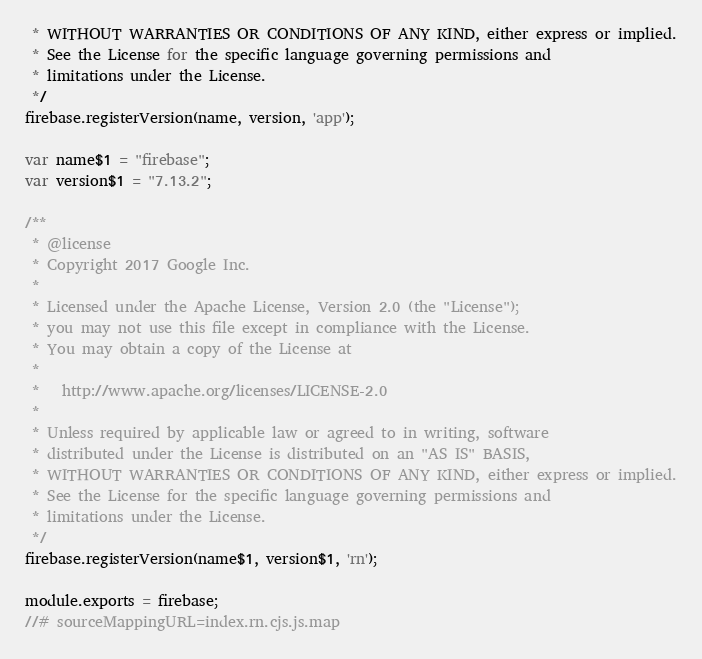<code> <loc_0><loc_0><loc_500><loc_500><_JavaScript_> * WITHOUT WARRANTIES OR CONDITIONS OF ANY KIND, either express or implied.
 * See the License for the specific language governing permissions and
 * limitations under the License.
 */
firebase.registerVersion(name, version, 'app');

var name$1 = "firebase";
var version$1 = "7.13.2";

/**
 * @license
 * Copyright 2017 Google Inc.
 *
 * Licensed under the Apache License, Version 2.0 (the "License");
 * you may not use this file except in compliance with the License.
 * You may obtain a copy of the License at
 *
 *   http://www.apache.org/licenses/LICENSE-2.0
 *
 * Unless required by applicable law or agreed to in writing, software
 * distributed under the License is distributed on an "AS IS" BASIS,
 * WITHOUT WARRANTIES OR CONDITIONS OF ANY KIND, either express or implied.
 * See the License for the specific language governing permissions and
 * limitations under the License.
 */
firebase.registerVersion(name$1, version$1, 'rn');

module.exports = firebase;
//# sourceMappingURL=index.rn.cjs.js.map
</code> 